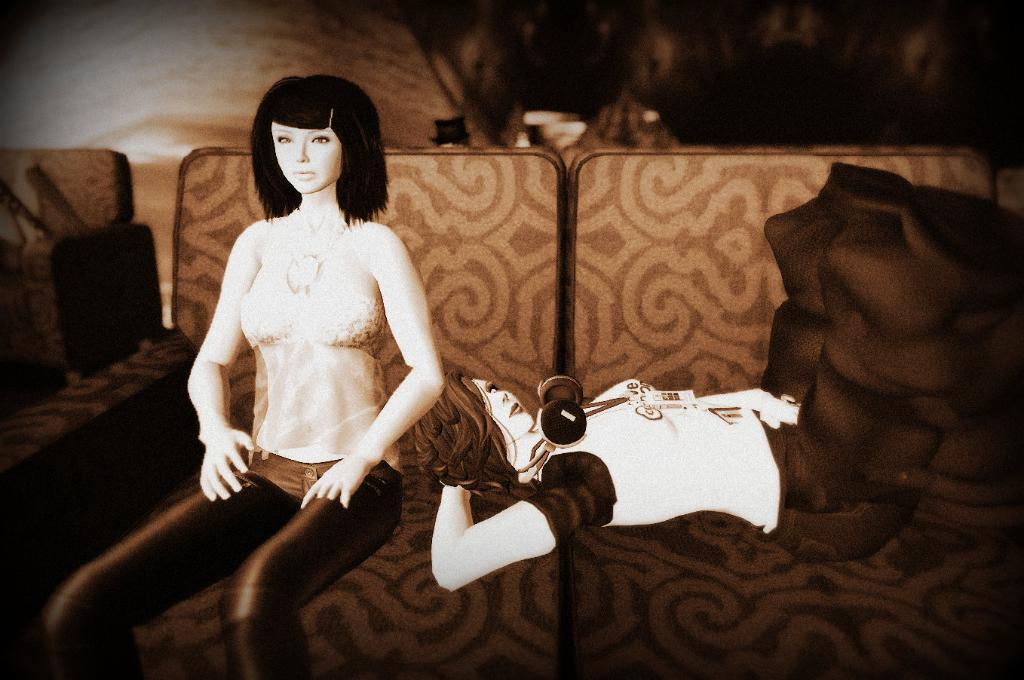What is the position of the first woman in the image? There is a woman sitting on the couch. What is the position of the second woman in the image? There is another woman lying on the couch. Can you describe the background of the image? The background of the image is blurred. What song is the woman singing in the image? There is no indication in the image that the woman is singing a song. 